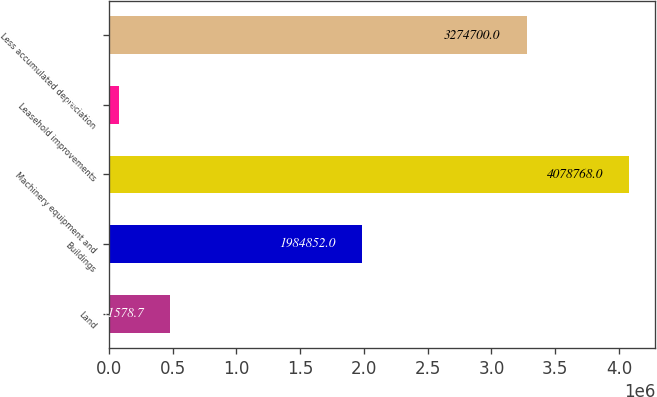Convert chart to OTSL. <chart><loc_0><loc_0><loc_500><loc_500><bar_chart><fcel>Land<fcel>Buildings<fcel>Machinery equipment and<fcel>Leasehold improvements<fcel>Less accumulated depreciation<nl><fcel>481579<fcel>1.98485e+06<fcel>4.07877e+06<fcel>81891<fcel>3.2747e+06<nl></chart> 